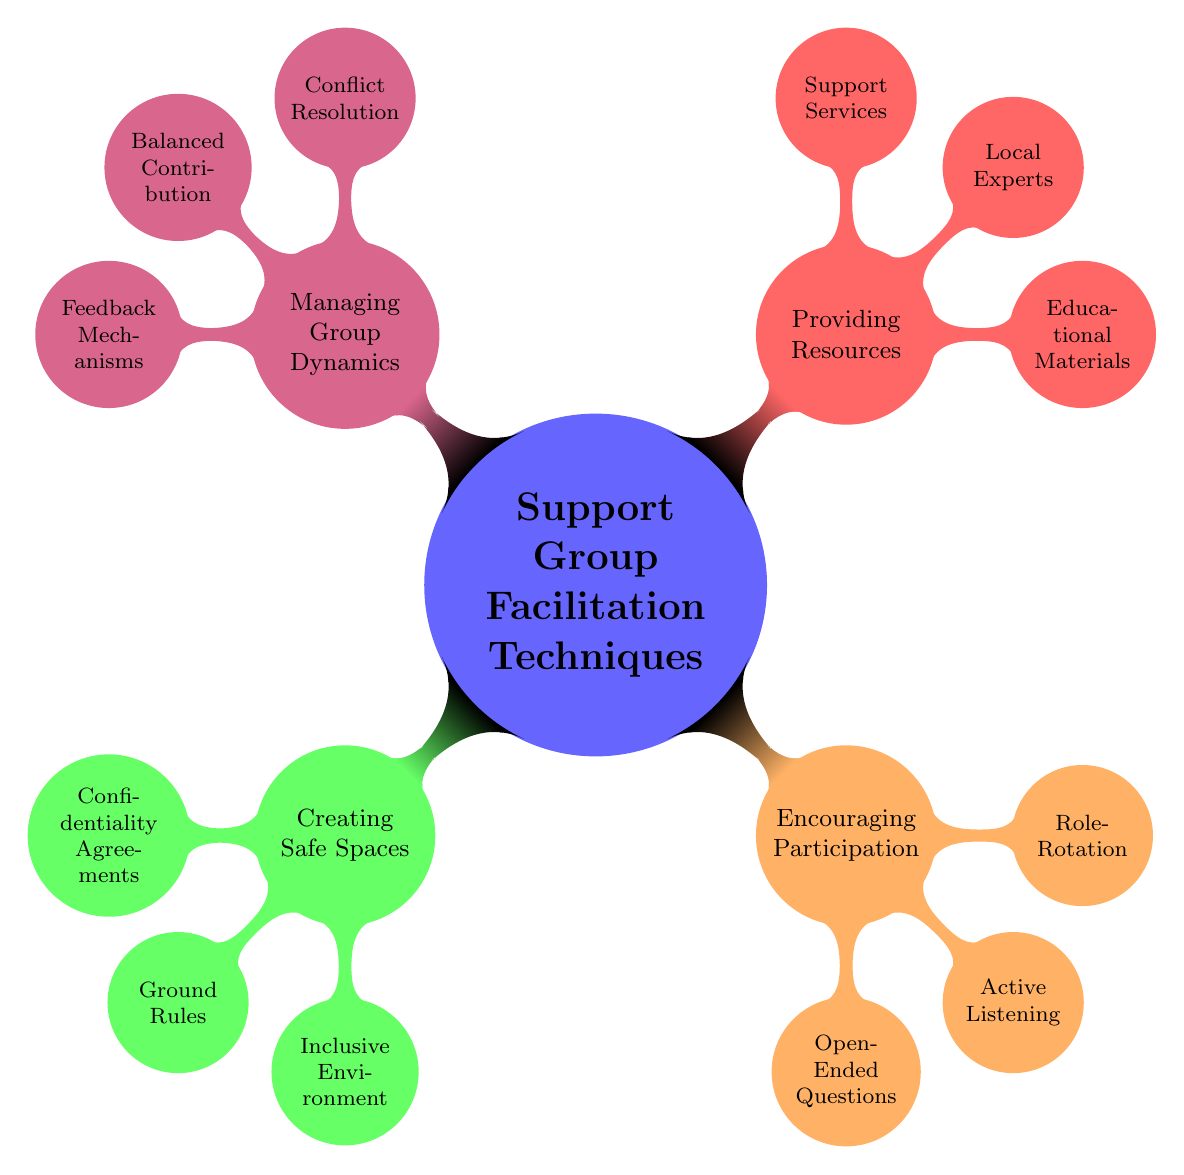What are the four main categories of support group facilitation techniques? The main categories visible in the diagram are Creating Safe Spaces, Encouraging Participation, Providing Resources, and Managing Group Dynamics.
Answer: Creating Safe Spaces, Encouraging Participation, Providing Resources, Managing Group Dynamics How many nodes are there under "Encouraging Participation"? Under the category Encouraging Participation, there are three nodes listed: Open-Ended Questions, Active Listening, and Role-Rotation.
Answer: 3 What technique involves signing an agreement to ensure trust? The technique related to signing an agreement for trust is "Confidentiality Agreements."
Answer: Confidentiality Agreements Which category includes "Feedback Mechanisms"? Feedback Mechanisms is a node under the category "Managing Group Dynamics."
Answer: Managing Group Dynamics Name one method of encouraging participation. One method included for encouraging participation is "Open-Ended Questions."
Answer: Open-Ended Questions What is a technique mentioned for managing conflict in groups? The technique mentioned for managing conflict is "Conflict Resolution."
Answer: Conflict Resolution In which category would you find "Educational Materials"? Educational Materials is found in the category "Providing Resources."
Answer: Providing Resources How does "Role-Rotation" help the group? Role-Rotation empowers different members by allowing them to take turns leading discussions within the group.
Answer: Empowers members What condition is stated for creating an inclusive environment? The condition stated for inclusivity is making considerations for disabilities.
Answer: Considerations for disabilities 